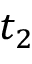<formula> <loc_0><loc_0><loc_500><loc_500>t _ { 2 }</formula> 